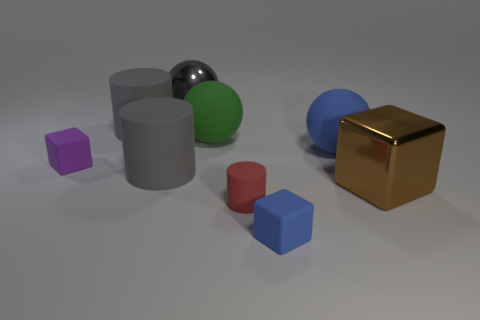Can you describe how shadows are used in this image to give a sense of depth? Certainly! The shadows in the image fall to the right, suggesting a light source coming from the left. The elongated shadows create a sense of three-dimensional form and give the impression that the objects are resting on a flat surface. The varying intensity and size of the shadows help to distinguish the distance and height of each object, further enhancing the perception of depth. 